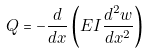<formula> <loc_0><loc_0><loc_500><loc_500>Q = - { \frac { d } { d x } } \left ( E I { \frac { d ^ { 2 } w } { d x ^ { 2 } } } \right )</formula> 